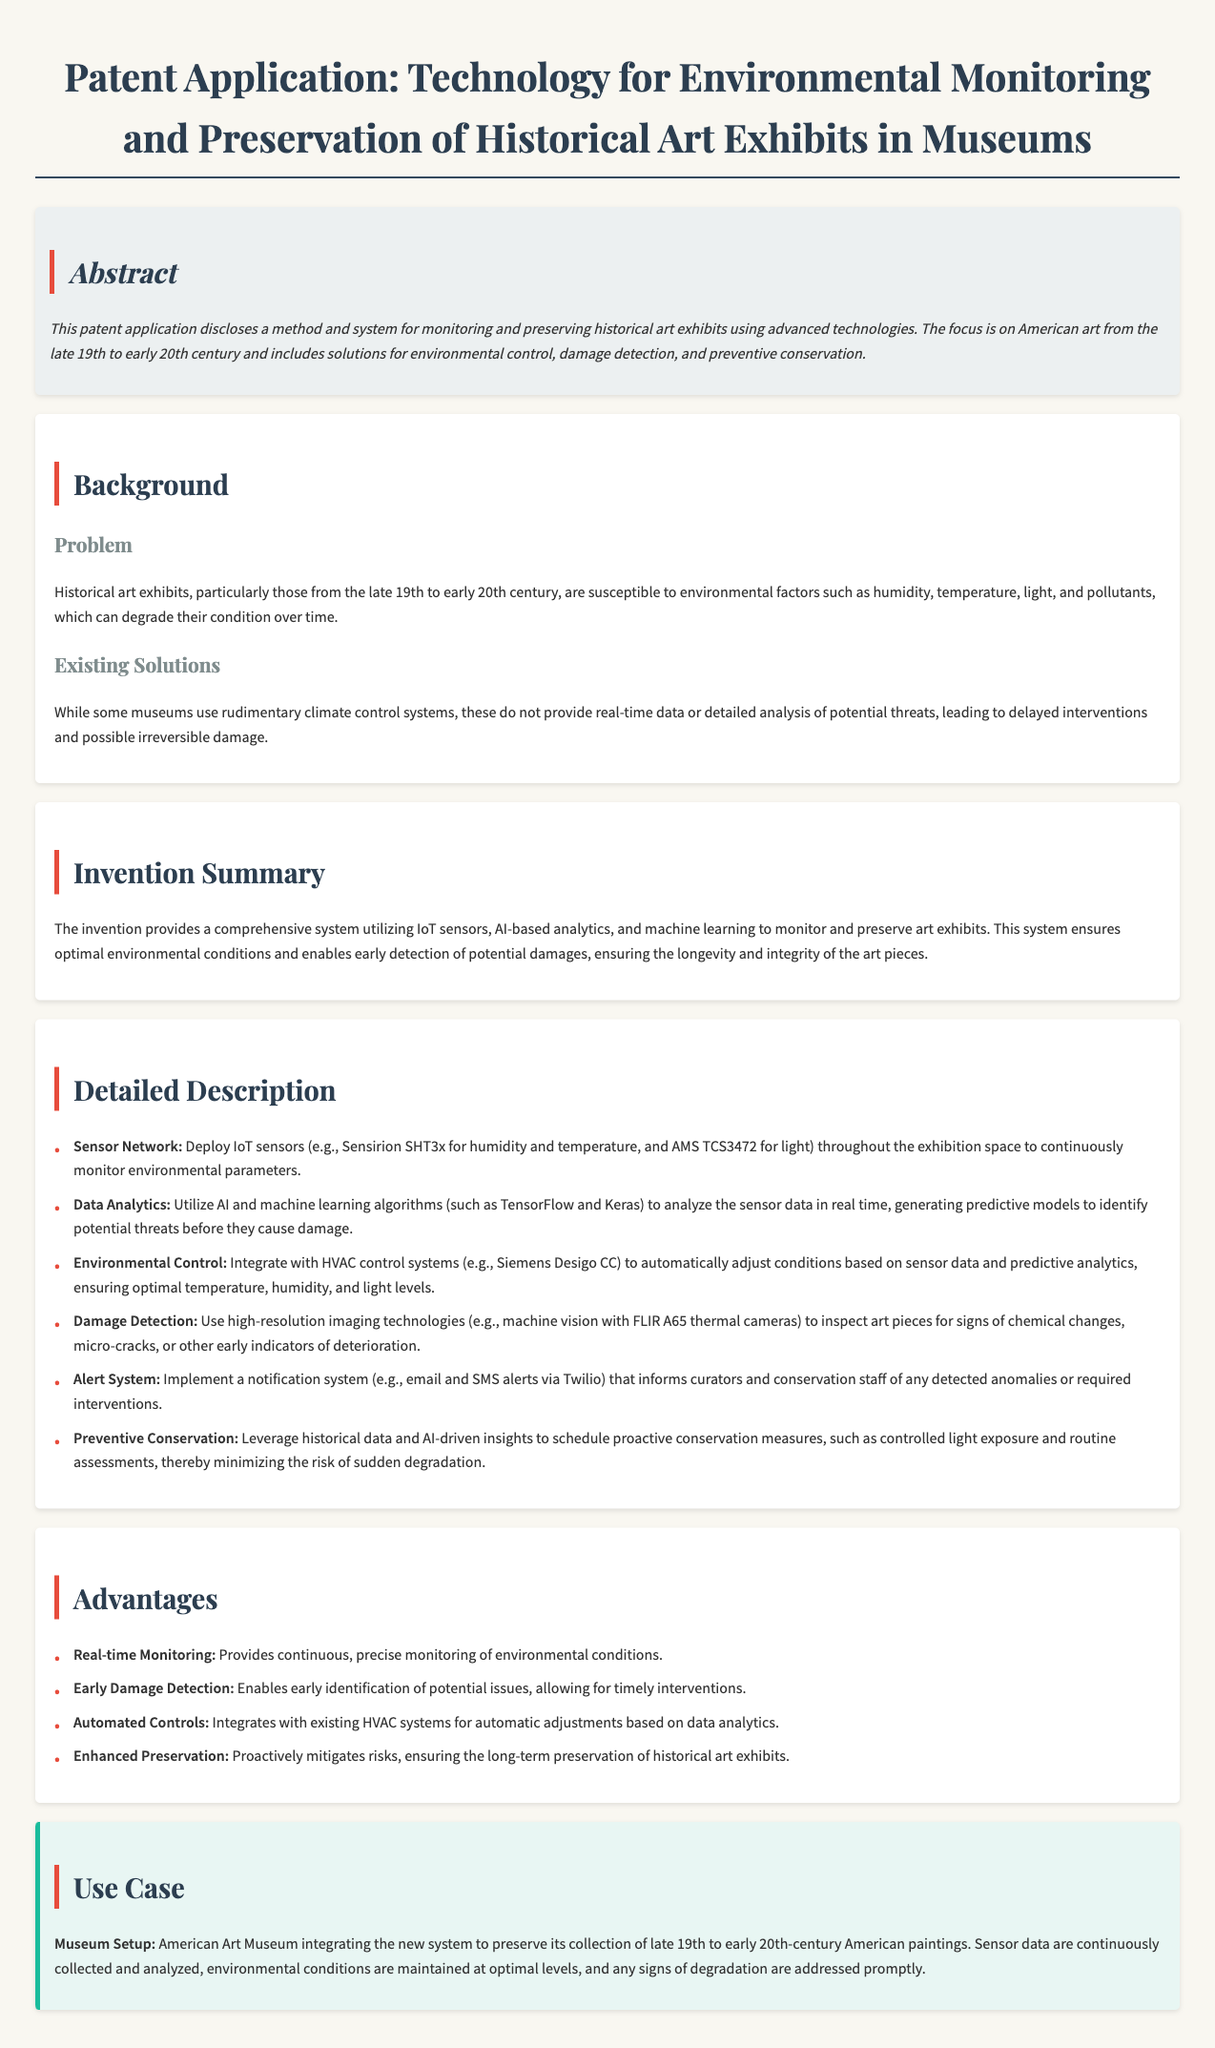What is the focus of the invention? The invention focuses on monitoring and preserving historical art exhibits, particularly American art from the late 19th to early 20th century.
Answer: American art from the late 19th to early 20th century What type of sensors are used in the sensor network? The patent mentions using IoT sensors, specifically Sensirion SHT3x for humidity and temperature.
Answer: Sensirion SHT3x What does the alert system inform curators about? The alert system informs curators of detected anomalies or required interventions.
Answer: Detected anomalies or required interventions What is one advantage of the proposed technology? One advantage mentioned is early damage detection, enabling timely interventions.
Answer: Early damage detection What technology is integrated with the HVAC control systems? The invention integrates with HVAC control systems such as Siemens Desigo CC.
Answer: Siemens Desigo CC Why are historical data leveraged in the system? Historical data is leveraged to schedule proactive conservation measures, minimizing the risk of sudden degradation.
Answer: To schedule proactive conservation measures What aims to be ensured through the new system? The system aims to ensure the longevity and integrity of the art pieces.
Answer: Longevity and integrity of the art pieces What is used for damage detection? High-resolution imaging technologies, specifically machine vision with FLIR A65 thermal cameras, are used for damage detection.
Answer: Machine vision with FLIR A65 thermal cameras 